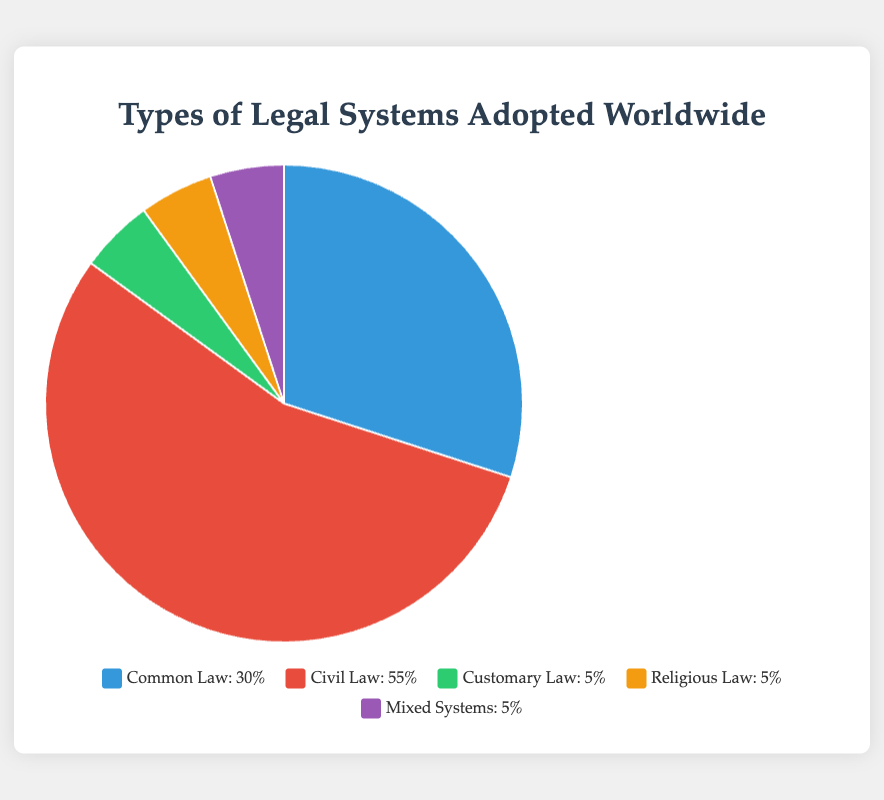Which type of legal system is the most widely adopted worldwide? The figure shows the percentage of each legal system adopted worldwide. The Civil Law system appears with the highest percentage at 55%, indicating it is the most widely adopted.
Answer: Civil Law What is the combined percentage of regions adopting Customary Law and Religious Law? The percentage of regions adopting Customary Law is 5%, and for Religious Law, it is also 5%. Adding these together gives 5% + 5% = 10%.
Answer: 10% How does the adoption rate of Common Law compare to that of Civil Law? The figure shows that Common Law has a 30% adoption rate, while Civil Law has a 55% adoption rate. Because 30% is less than 55%, Common Law is less widely adopted compared to Civil Law.
Answer: Common Law is less widely adopted than Civil Law Which legal systems have the same adoption percentage worldwide? Reviewing the figure, Customary Law, Religious Law, and Mixed Systems each have an adoption percentage of 5%.
Answer: Customary Law, Religious Law, and Mixed Systems What is the difference in adoption rates between Common Law and the least adopted system? Common Law is adopted by 30% of regions, while the least adopted systems (Customary Law, Religious Law, and Mixed Systems) each have a 5% adoption rate. The difference is 30% - 5% = 25%.
Answer: 25% If the regions adopting the Civil Law system represent 55%, what is their combined proportion in comparison to all other systems collectively? The Civil Law system accounts for 55%, while all other systems combined (30% + 5% + 5% + 5%) total 45%. Comparing these proportions: 55% (Civil Law) against 45% (all other systems).
Answer: Civil Law's proportion is greater than all others combined In terms of the pie chart colors, which system is represented by the blue section? According to the color coding in the description, the blue section of the pie chart represents the Common Law system.
Answer: Common Law What is the total percentage represented by systems other than Civil Law? Civil Law represents 55%, so the remaining percentage combining all other systems is 100% - 55% = 45%.
Answer: 45% If two new regions adopt Mixed Systems, how would this affect its representation percentage-wise, assuming the total number of regions remains the same? Without additional exact data on the number of regions, percentage changes cannot be calculated precisely. However, the current percentage (5%) would increase to a higher value with the addition of any new regions.
Answer: Increase (cannot specify exact percentage) 